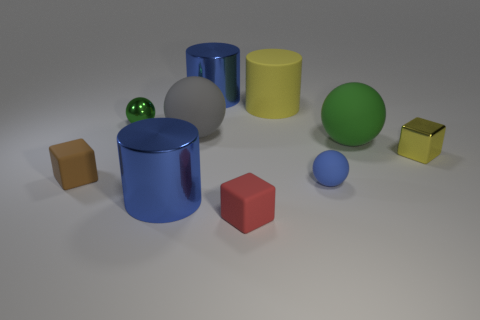There is a red object that is made of the same material as the yellow cylinder; what size is it?
Your answer should be compact. Small. Is there anything else of the same color as the shiny block?
Provide a succinct answer. Yes. Does the brown cube have the same material as the tiny blue object that is behind the red matte block?
Offer a terse response. Yes. There is a large green object that is the same shape as the tiny blue rubber thing; what is it made of?
Your answer should be very brief. Rubber. Do the large blue cylinder behind the brown matte object and the yellow thing to the right of the small blue thing have the same material?
Offer a terse response. Yes. There is a small matte cube on the right side of the large metal thing that is left of the large blue cylinder behind the yellow block; what is its color?
Your response must be concise. Red. How many other objects are there of the same shape as the big green rubber object?
Provide a succinct answer. 3. Is the color of the small shiny block the same as the matte cylinder?
Your answer should be very brief. Yes. How many things are either blue shiny balls or objects in front of the small yellow cube?
Provide a succinct answer. 4. Are there any yellow cubes that have the same size as the gray ball?
Make the answer very short. No. 